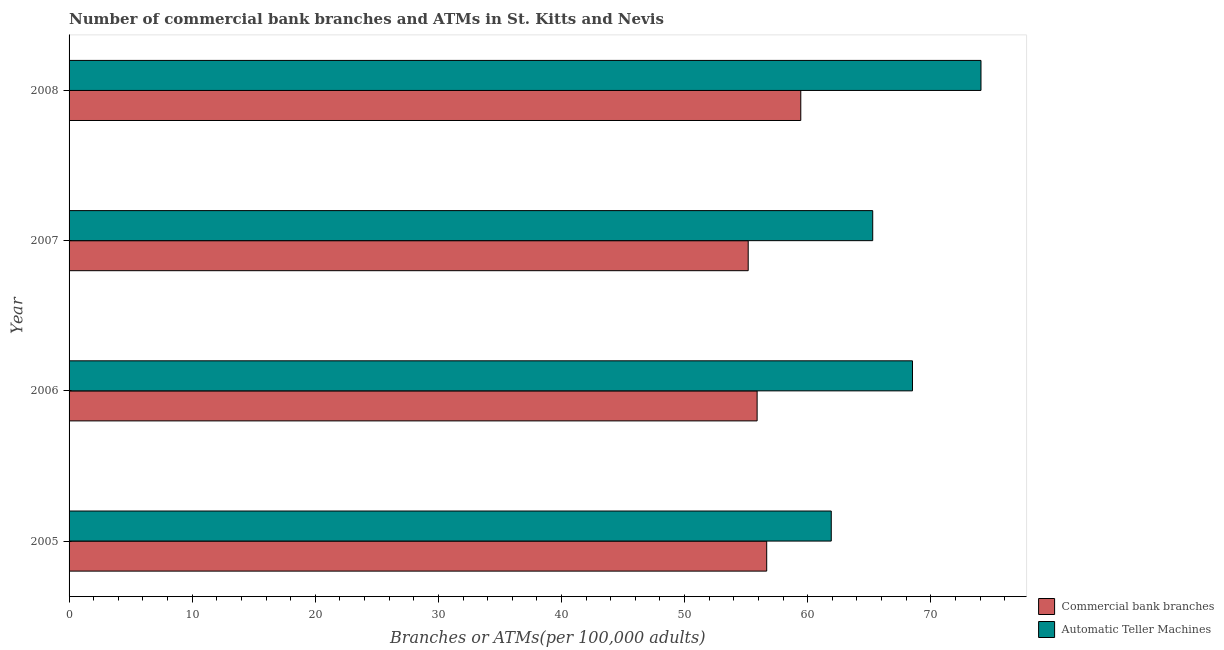How many different coloured bars are there?
Give a very brief answer. 2. Are the number of bars per tick equal to the number of legend labels?
Offer a very short reply. Yes. Are the number of bars on each tick of the Y-axis equal?
Provide a short and direct response. Yes. How many bars are there on the 1st tick from the bottom?
Provide a short and direct response. 2. What is the number of commercal bank branches in 2008?
Your answer should be very brief. 59.44. Across all years, what is the maximum number of atms?
Keep it short and to the point. 74.08. Across all years, what is the minimum number of atms?
Offer a very short reply. 61.92. In which year was the number of commercal bank branches minimum?
Offer a very short reply. 2007. What is the total number of commercal bank branches in the graph?
Your answer should be very brief. 227.17. What is the difference between the number of atms in 2005 and that in 2007?
Give a very brief answer. -3.37. What is the difference between the number of commercal bank branches in 2005 and the number of atms in 2008?
Your response must be concise. -17.41. What is the average number of atms per year?
Provide a succinct answer. 67.45. In the year 2006, what is the difference between the number of commercal bank branches and number of atms?
Offer a very short reply. -12.62. What is the ratio of the number of commercal bank branches in 2007 to that in 2008?
Your answer should be very brief. 0.93. Is the difference between the number of commercal bank branches in 2006 and 2007 greater than the difference between the number of atms in 2006 and 2007?
Offer a terse response. No. What is the difference between the highest and the second highest number of atms?
Keep it short and to the point. 5.57. What is the difference between the highest and the lowest number of commercal bank branches?
Offer a terse response. 4.27. In how many years, is the number of atms greater than the average number of atms taken over all years?
Your answer should be very brief. 2. Is the sum of the number of commercal bank branches in 2005 and 2006 greater than the maximum number of atms across all years?
Keep it short and to the point. Yes. What does the 1st bar from the top in 2008 represents?
Provide a short and direct response. Automatic Teller Machines. What does the 1st bar from the bottom in 2007 represents?
Offer a very short reply. Commercial bank branches. How many bars are there?
Your answer should be very brief. 8. Are all the bars in the graph horizontal?
Offer a very short reply. Yes. What is the difference between two consecutive major ticks on the X-axis?
Provide a succinct answer. 10. Are the values on the major ticks of X-axis written in scientific E-notation?
Your answer should be very brief. No. Does the graph contain grids?
Keep it short and to the point. No. Where does the legend appear in the graph?
Provide a succinct answer. Bottom right. How many legend labels are there?
Keep it short and to the point. 2. How are the legend labels stacked?
Your answer should be very brief. Vertical. What is the title of the graph?
Provide a succinct answer. Number of commercial bank branches and ATMs in St. Kitts and Nevis. What is the label or title of the X-axis?
Your answer should be very brief. Branches or ATMs(per 100,0 adults). What is the Branches or ATMs(per 100,000 adults) of Commercial bank branches in 2005?
Ensure brevity in your answer.  56.67. What is the Branches or ATMs(per 100,000 adults) of Automatic Teller Machines in 2005?
Make the answer very short. 61.92. What is the Branches or ATMs(per 100,000 adults) of Commercial bank branches in 2006?
Ensure brevity in your answer.  55.89. What is the Branches or ATMs(per 100,000 adults) of Automatic Teller Machines in 2006?
Offer a very short reply. 68.51. What is the Branches or ATMs(per 100,000 adults) of Commercial bank branches in 2007?
Your response must be concise. 55.17. What is the Branches or ATMs(per 100,000 adults) of Automatic Teller Machines in 2007?
Your response must be concise. 65.28. What is the Branches or ATMs(per 100,000 adults) in Commercial bank branches in 2008?
Ensure brevity in your answer.  59.44. What is the Branches or ATMs(per 100,000 adults) of Automatic Teller Machines in 2008?
Provide a succinct answer. 74.08. Across all years, what is the maximum Branches or ATMs(per 100,000 adults) of Commercial bank branches?
Provide a short and direct response. 59.44. Across all years, what is the maximum Branches or ATMs(per 100,000 adults) in Automatic Teller Machines?
Offer a very short reply. 74.08. Across all years, what is the minimum Branches or ATMs(per 100,000 adults) of Commercial bank branches?
Ensure brevity in your answer.  55.17. Across all years, what is the minimum Branches or ATMs(per 100,000 adults) in Automatic Teller Machines?
Offer a very short reply. 61.92. What is the total Branches or ATMs(per 100,000 adults) in Commercial bank branches in the graph?
Keep it short and to the point. 227.17. What is the total Branches or ATMs(per 100,000 adults) in Automatic Teller Machines in the graph?
Your answer should be compact. 269.79. What is the difference between the Branches or ATMs(per 100,000 adults) in Commercial bank branches in 2005 and that in 2006?
Your answer should be very brief. 0.78. What is the difference between the Branches or ATMs(per 100,000 adults) in Automatic Teller Machines in 2005 and that in 2006?
Provide a short and direct response. -6.6. What is the difference between the Branches or ATMs(per 100,000 adults) in Commercial bank branches in 2005 and that in 2007?
Your response must be concise. 1.5. What is the difference between the Branches or ATMs(per 100,000 adults) of Automatic Teller Machines in 2005 and that in 2007?
Offer a very short reply. -3.37. What is the difference between the Branches or ATMs(per 100,000 adults) of Commercial bank branches in 2005 and that in 2008?
Provide a succinct answer. -2.77. What is the difference between the Branches or ATMs(per 100,000 adults) of Automatic Teller Machines in 2005 and that in 2008?
Provide a short and direct response. -12.16. What is the difference between the Branches or ATMs(per 100,000 adults) of Commercial bank branches in 2006 and that in 2007?
Keep it short and to the point. 0.73. What is the difference between the Branches or ATMs(per 100,000 adults) in Automatic Teller Machines in 2006 and that in 2007?
Your answer should be compact. 3.23. What is the difference between the Branches or ATMs(per 100,000 adults) of Commercial bank branches in 2006 and that in 2008?
Provide a succinct answer. -3.55. What is the difference between the Branches or ATMs(per 100,000 adults) of Automatic Teller Machines in 2006 and that in 2008?
Ensure brevity in your answer.  -5.57. What is the difference between the Branches or ATMs(per 100,000 adults) in Commercial bank branches in 2007 and that in 2008?
Offer a terse response. -4.27. What is the difference between the Branches or ATMs(per 100,000 adults) in Automatic Teller Machines in 2007 and that in 2008?
Your answer should be compact. -8.8. What is the difference between the Branches or ATMs(per 100,000 adults) in Commercial bank branches in 2005 and the Branches or ATMs(per 100,000 adults) in Automatic Teller Machines in 2006?
Offer a very short reply. -11.84. What is the difference between the Branches or ATMs(per 100,000 adults) in Commercial bank branches in 2005 and the Branches or ATMs(per 100,000 adults) in Automatic Teller Machines in 2007?
Provide a short and direct response. -8.61. What is the difference between the Branches or ATMs(per 100,000 adults) of Commercial bank branches in 2005 and the Branches or ATMs(per 100,000 adults) of Automatic Teller Machines in 2008?
Your answer should be compact. -17.41. What is the difference between the Branches or ATMs(per 100,000 adults) in Commercial bank branches in 2006 and the Branches or ATMs(per 100,000 adults) in Automatic Teller Machines in 2007?
Your response must be concise. -9.39. What is the difference between the Branches or ATMs(per 100,000 adults) of Commercial bank branches in 2006 and the Branches or ATMs(per 100,000 adults) of Automatic Teller Machines in 2008?
Keep it short and to the point. -18.19. What is the difference between the Branches or ATMs(per 100,000 adults) in Commercial bank branches in 2007 and the Branches or ATMs(per 100,000 adults) in Automatic Teller Machines in 2008?
Your answer should be compact. -18.91. What is the average Branches or ATMs(per 100,000 adults) of Commercial bank branches per year?
Offer a terse response. 56.79. What is the average Branches or ATMs(per 100,000 adults) in Automatic Teller Machines per year?
Ensure brevity in your answer.  67.45. In the year 2005, what is the difference between the Branches or ATMs(per 100,000 adults) of Commercial bank branches and Branches or ATMs(per 100,000 adults) of Automatic Teller Machines?
Keep it short and to the point. -5.24. In the year 2006, what is the difference between the Branches or ATMs(per 100,000 adults) in Commercial bank branches and Branches or ATMs(per 100,000 adults) in Automatic Teller Machines?
Your answer should be compact. -12.62. In the year 2007, what is the difference between the Branches or ATMs(per 100,000 adults) in Commercial bank branches and Branches or ATMs(per 100,000 adults) in Automatic Teller Machines?
Your answer should be very brief. -10.11. In the year 2008, what is the difference between the Branches or ATMs(per 100,000 adults) in Commercial bank branches and Branches or ATMs(per 100,000 adults) in Automatic Teller Machines?
Keep it short and to the point. -14.64. What is the ratio of the Branches or ATMs(per 100,000 adults) of Commercial bank branches in 2005 to that in 2006?
Your response must be concise. 1.01. What is the ratio of the Branches or ATMs(per 100,000 adults) in Automatic Teller Machines in 2005 to that in 2006?
Make the answer very short. 0.9. What is the ratio of the Branches or ATMs(per 100,000 adults) of Commercial bank branches in 2005 to that in 2007?
Your response must be concise. 1.03. What is the ratio of the Branches or ATMs(per 100,000 adults) of Automatic Teller Machines in 2005 to that in 2007?
Provide a succinct answer. 0.95. What is the ratio of the Branches or ATMs(per 100,000 adults) in Commercial bank branches in 2005 to that in 2008?
Provide a succinct answer. 0.95. What is the ratio of the Branches or ATMs(per 100,000 adults) of Automatic Teller Machines in 2005 to that in 2008?
Your answer should be very brief. 0.84. What is the ratio of the Branches or ATMs(per 100,000 adults) in Commercial bank branches in 2006 to that in 2007?
Offer a terse response. 1.01. What is the ratio of the Branches or ATMs(per 100,000 adults) in Automatic Teller Machines in 2006 to that in 2007?
Provide a succinct answer. 1.05. What is the ratio of the Branches or ATMs(per 100,000 adults) of Commercial bank branches in 2006 to that in 2008?
Your answer should be compact. 0.94. What is the ratio of the Branches or ATMs(per 100,000 adults) in Automatic Teller Machines in 2006 to that in 2008?
Make the answer very short. 0.92. What is the ratio of the Branches or ATMs(per 100,000 adults) of Commercial bank branches in 2007 to that in 2008?
Provide a short and direct response. 0.93. What is the ratio of the Branches or ATMs(per 100,000 adults) of Automatic Teller Machines in 2007 to that in 2008?
Keep it short and to the point. 0.88. What is the difference between the highest and the second highest Branches or ATMs(per 100,000 adults) in Commercial bank branches?
Your answer should be compact. 2.77. What is the difference between the highest and the second highest Branches or ATMs(per 100,000 adults) in Automatic Teller Machines?
Give a very brief answer. 5.57. What is the difference between the highest and the lowest Branches or ATMs(per 100,000 adults) in Commercial bank branches?
Keep it short and to the point. 4.27. What is the difference between the highest and the lowest Branches or ATMs(per 100,000 adults) of Automatic Teller Machines?
Make the answer very short. 12.16. 